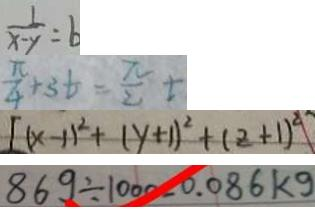Convert formula to latex. <formula><loc_0><loc_0><loc_500><loc_500>\frac { 1 } { x - y } = b 
 \frac { \pi } { 4 } + 3 t = \frac { \pi } { 2 } t 
 [ ( x - 1 ) ^ { 2 } + ( y + 1 ) ^ { 2 } + ( z + 1 ) ^ { 2 } ] 
 8 6 9 \div 1 0 0 0 - 0 . 0 8 6 k g</formula> 